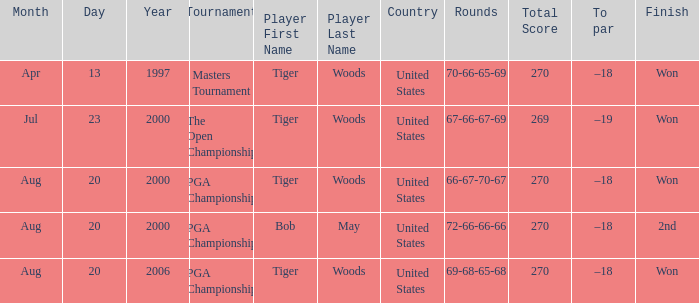What is the worst (highest) score? 270.0. 